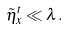Convert formula to latex. <formula><loc_0><loc_0><loc_500><loc_500>\tilde { \eta } _ { x } ^ { t } \ll \lambda .</formula> 